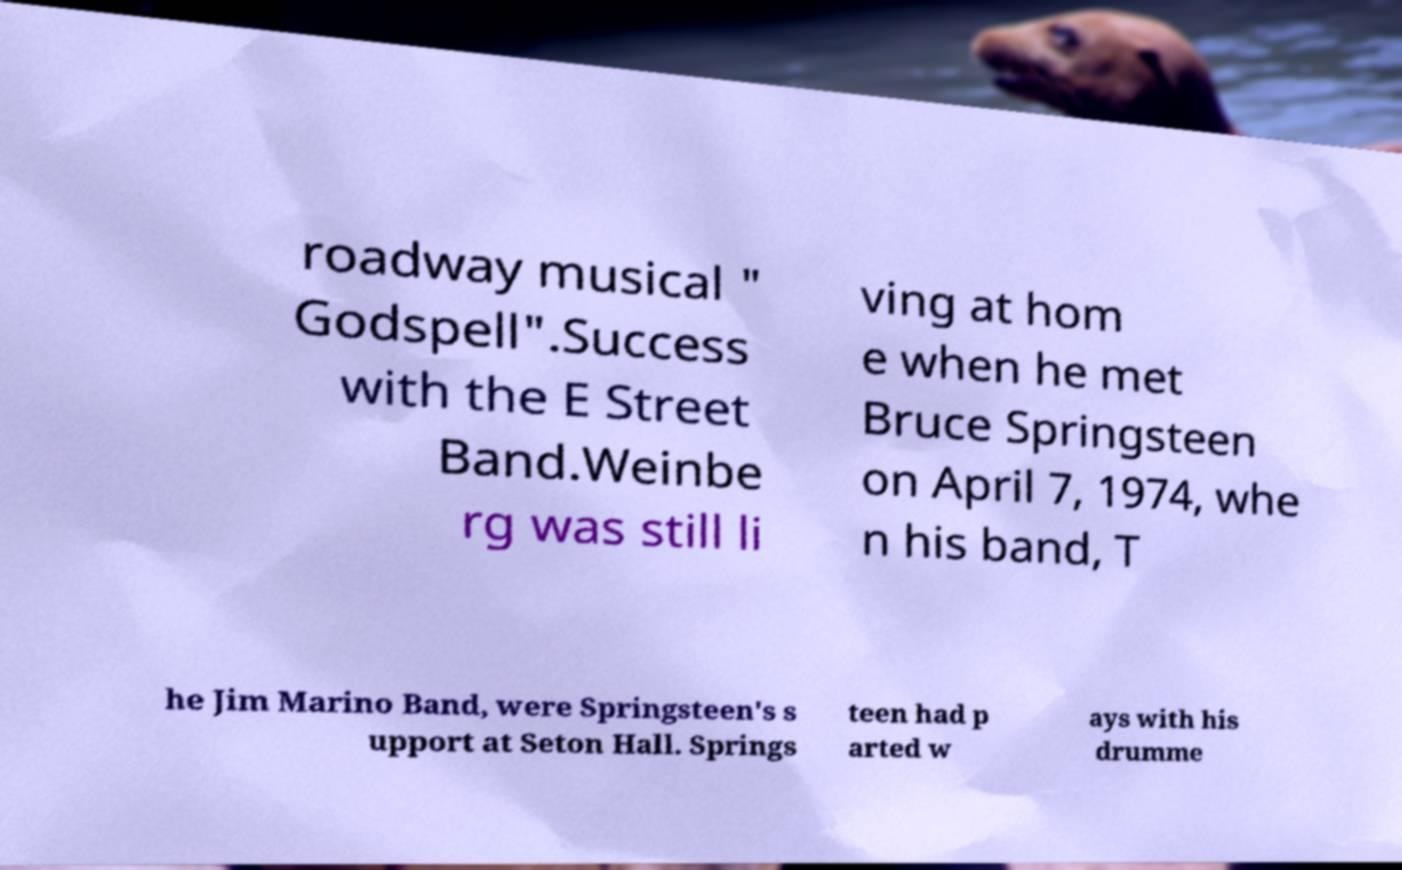What messages or text are displayed in this image? I need them in a readable, typed format. roadway musical " Godspell".Success with the E Street Band.Weinbe rg was still li ving at hom e when he met Bruce Springsteen on April 7, 1974, whe n his band, T he Jim Marino Band, were Springsteen's s upport at Seton Hall. Springs teen had p arted w ays with his drumme 